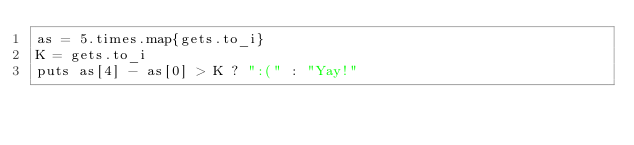<code> <loc_0><loc_0><loc_500><loc_500><_Ruby_>as = 5.times.map{gets.to_i}
K = gets.to_i
puts as[4] - as[0] > K ? ":(" : "Yay!"</code> 